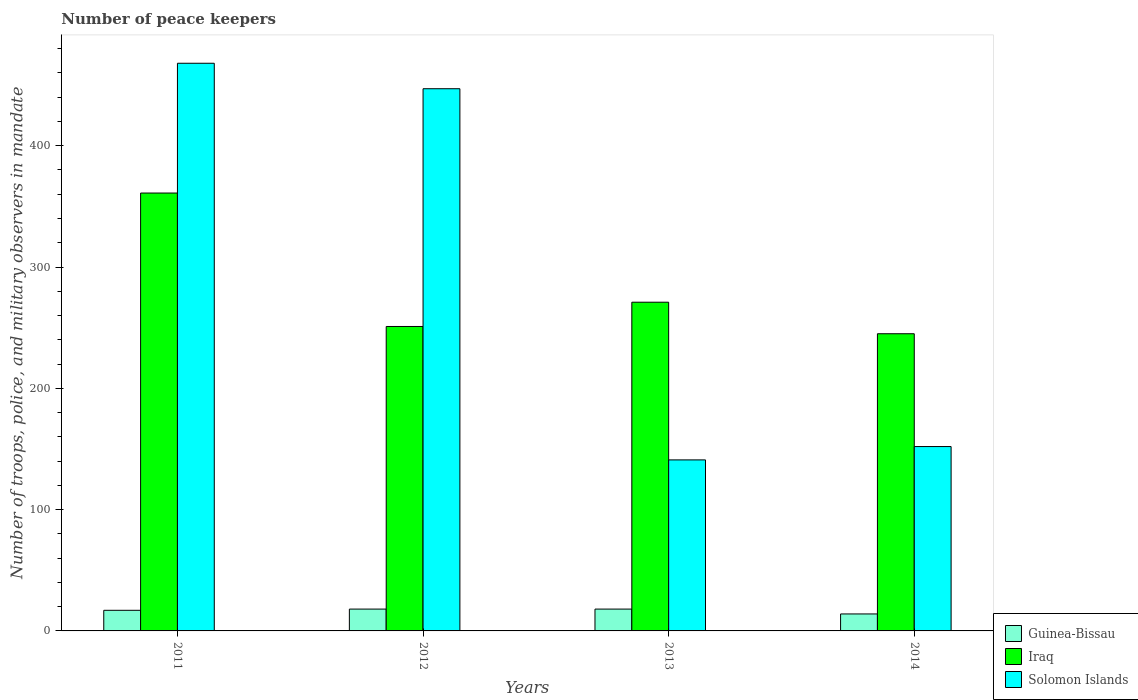How many different coloured bars are there?
Your response must be concise. 3. How many bars are there on the 4th tick from the right?
Offer a terse response. 3. What is the number of peace keepers in in Solomon Islands in 2013?
Ensure brevity in your answer.  141. Across all years, what is the maximum number of peace keepers in in Solomon Islands?
Provide a succinct answer. 468. What is the total number of peace keepers in in Solomon Islands in the graph?
Provide a short and direct response. 1208. What is the difference between the number of peace keepers in in Solomon Islands in 2012 and that in 2013?
Offer a terse response. 306. What is the difference between the number of peace keepers in in Guinea-Bissau in 2012 and the number of peace keepers in in Solomon Islands in 2013?
Your answer should be compact. -123. What is the average number of peace keepers in in Guinea-Bissau per year?
Offer a terse response. 16.75. In the year 2014, what is the difference between the number of peace keepers in in Guinea-Bissau and number of peace keepers in in Iraq?
Give a very brief answer. -231. What is the ratio of the number of peace keepers in in Solomon Islands in 2011 to that in 2012?
Your answer should be compact. 1.05. Is the number of peace keepers in in Solomon Islands in 2012 less than that in 2013?
Offer a very short reply. No. Is the difference between the number of peace keepers in in Guinea-Bissau in 2012 and 2013 greater than the difference between the number of peace keepers in in Iraq in 2012 and 2013?
Your answer should be compact. Yes. What is the difference between the highest and the second highest number of peace keepers in in Guinea-Bissau?
Offer a very short reply. 0. What is the difference between the highest and the lowest number of peace keepers in in Solomon Islands?
Give a very brief answer. 327. In how many years, is the number of peace keepers in in Iraq greater than the average number of peace keepers in in Iraq taken over all years?
Ensure brevity in your answer.  1. Is the sum of the number of peace keepers in in Iraq in 2013 and 2014 greater than the maximum number of peace keepers in in Guinea-Bissau across all years?
Your response must be concise. Yes. What does the 2nd bar from the left in 2014 represents?
Provide a succinct answer. Iraq. What does the 3rd bar from the right in 2011 represents?
Provide a succinct answer. Guinea-Bissau. How many bars are there?
Provide a short and direct response. 12. Are the values on the major ticks of Y-axis written in scientific E-notation?
Make the answer very short. No. Does the graph contain any zero values?
Offer a very short reply. No. How are the legend labels stacked?
Your response must be concise. Vertical. What is the title of the graph?
Keep it short and to the point. Number of peace keepers. What is the label or title of the Y-axis?
Give a very brief answer. Number of troops, police, and military observers in mandate. What is the Number of troops, police, and military observers in mandate of Iraq in 2011?
Keep it short and to the point. 361. What is the Number of troops, police, and military observers in mandate in Solomon Islands in 2011?
Your response must be concise. 468. What is the Number of troops, police, and military observers in mandate of Guinea-Bissau in 2012?
Ensure brevity in your answer.  18. What is the Number of troops, police, and military observers in mandate in Iraq in 2012?
Offer a terse response. 251. What is the Number of troops, police, and military observers in mandate in Solomon Islands in 2012?
Offer a terse response. 447. What is the Number of troops, police, and military observers in mandate in Guinea-Bissau in 2013?
Offer a very short reply. 18. What is the Number of troops, police, and military observers in mandate of Iraq in 2013?
Give a very brief answer. 271. What is the Number of troops, police, and military observers in mandate of Solomon Islands in 2013?
Offer a terse response. 141. What is the Number of troops, police, and military observers in mandate of Iraq in 2014?
Provide a short and direct response. 245. What is the Number of troops, police, and military observers in mandate in Solomon Islands in 2014?
Offer a very short reply. 152. Across all years, what is the maximum Number of troops, police, and military observers in mandate in Iraq?
Provide a succinct answer. 361. Across all years, what is the maximum Number of troops, police, and military observers in mandate of Solomon Islands?
Your answer should be compact. 468. Across all years, what is the minimum Number of troops, police, and military observers in mandate in Iraq?
Your answer should be compact. 245. Across all years, what is the minimum Number of troops, police, and military observers in mandate of Solomon Islands?
Make the answer very short. 141. What is the total Number of troops, police, and military observers in mandate of Guinea-Bissau in the graph?
Offer a terse response. 67. What is the total Number of troops, police, and military observers in mandate in Iraq in the graph?
Offer a very short reply. 1128. What is the total Number of troops, police, and military observers in mandate in Solomon Islands in the graph?
Ensure brevity in your answer.  1208. What is the difference between the Number of troops, police, and military observers in mandate in Iraq in 2011 and that in 2012?
Give a very brief answer. 110. What is the difference between the Number of troops, police, and military observers in mandate of Solomon Islands in 2011 and that in 2012?
Ensure brevity in your answer.  21. What is the difference between the Number of troops, police, and military observers in mandate of Solomon Islands in 2011 and that in 2013?
Give a very brief answer. 327. What is the difference between the Number of troops, police, and military observers in mandate of Iraq in 2011 and that in 2014?
Ensure brevity in your answer.  116. What is the difference between the Number of troops, police, and military observers in mandate in Solomon Islands in 2011 and that in 2014?
Provide a succinct answer. 316. What is the difference between the Number of troops, police, and military observers in mandate of Guinea-Bissau in 2012 and that in 2013?
Provide a succinct answer. 0. What is the difference between the Number of troops, police, and military observers in mandate of Iraq in 2012 and that in 2013?
Keep it short and to the point. -20. What is the difference between the Number of troops, police, and military observers in mandate of Solomon Islands in 2012 and that in 2013?
Provide a succinct answer. 306. What is the difference between the Number of troops, police, and military observers in mandate of Solomon Islands in 2012 and that in 2014?
Your answer should be very brief. 295. What is the difference between the Number of troops, police, and military observers in mandate in Solomon Islands in 2013 and that in 2014?
Ensure brevity in your answer.  -11. What is the difference between the Number of troops, police, and military observers in mandate in Guinea-Bissau in 2011 and the Number of troops, police, and military observers in mandate in Iraq in 2012?
Keep it short and to the point. -234. What is the difference between the Number of troops, police, and military observers in mandate in Guinea-Bissau in 2011 and the Number of troops, police, and military observers in mandate in Solomon Islands in 2012?
Give a very brief answer. -430. What is the difference between the Number of troops, police, and military observers in mandate of Iraq in 2011 and the Number of troops, police, and military observers in mandate of Solomon Islands in 2012?
Your answer should be compact. -86. What is the difference between the Number of troops, police, and military observers in mandate in Guinea-Bissau in 2011 and the Number of troops, police, and military observers in mandate in Iraq in 2013?
Offer a very short reply. -254. What is the difference between the Number of troops, police, and military observers in mandate of Guinea-Bissau in 2011 and the Number of troops, police, and military observers in mandate of Solomon Islands in 2013?
Offer a very short reply. -124. What is the difference between the Number of troops, police, and military observers in mandate of Iraq in 2011 and the Number of troops, police, and military observers in mandate of Solomon Islands in 2013?
Keep it short and to the point. 220. What is the difference between the Number of troops, police, and military observers in mandate of Guinea-Bissau in 2011 and the Number of troops, police, and military observers in mandate of Iraq in 2014?
Give a very brief answer. -228. What is the difference between the Number of troops, police, and military observers in mandate in Guinea-Bissau in 2011 and the Number of troops, police, and military observers in mandate in Solomon Islands in 2014?
Offer a terse response. -135. What is the difference between the Number of troops, police, and military observers in mandate of Iraq in 2011 and the Number of troops, police, and military observers in mandate of Solomon Islands in 2014?
Your answer should be compact. 209. What is the difference between the Number of troops, police, and military observers in mandate of Guinea-Bissau in 2012 and the Number of troops, police, and military observers in mandate of Iraq in 2013?
Keep it short and to the point. -253. What is the difference between the Number of troops, police, and military observers in mandate of Guinea-Bissau in 2012 and the Number of troops, police, and military observers in mandate of Solomon Islands in 2013?
Keep it short and to the point. -123. What is the difference between the Number of troops, police, and military observers in mandate of Iraq in 2012 and the Number of troops, police, and military observers in mandate of Solomon Islands in 2013?
Give a very brief answer. 110. What is the difference between the Number of troops, police, and military observers in mandate of Guinea-Bissau in 2012 and the Number of troops, police, and military observers in mandate of Iraq in 2014?
Provide a succinct answer. -227. What is the difference between the Number of troops, police, and military observers in mandate in Guinea-Bissau in 2012 and the Number of troops, police, and military observers in mandate in Solomon Islands in 2014?
Your answer should be compact. -134. What is the difference between the Number of troops, police, and military observers in mandate of Guinea-Bissau in 2013 and the Number of troops, police, and military observers in mandate of Iraq in 2014?
Ensure brevity in your answer.  -227. What is the difference between the Number of troops, police, and military observers in mandate of Guinea-Bissau in 2013 and the Number of troops, police, and military observers in mandate of Solomon Islands in 2014?
Your response must be concise. -134. What is the difference between the Number of troops, police, and military observers in mandate in Iraq in 2013 and the Number of troops, police, and military observers in mandate in Solomon Islands in 2014?
Offer a very short reply. 119. What is the average Number of troops, police, and military observers in mandate of Guinea-Bissau per year?
Make the answer very short. 16.75. What is the average Number of troops, police, and military observers in mandate of Iraq per year?
Your response must be concise. 282. What is the average Number of troops, police, and military observers in mandate of Solomon Islands per year?
Provide a succinct answer. 302. In the year 2011, what is the difference between the Number of troops, police, and military observers in mandate in Guinea-Bissau and Number of troops, police, and military observers in mandate in Iraq?
Keep it short and to the point. -344. In the year 2011, what is the difference between the Number of troops, police, and military observers in mandate in Guinea-Bissau and Number of troops, police, and military observers in mandate in Solomon Islands?
Ensure brevity in your answer.  -451. In the year 2011, what is the difference between the Number of troops, police, and military observers in mandate in Iraq and Number of troops, police, and military observers in mandate in Solomon Islands?
Make the answer very short. -107. In the year 2012, what is the difference between the Number of troops, police, and military observers in mandate of Guinea-Bissau and Number of troops, police, and military observers in mandate of Iraq?
Give a very brief answer. -233. In the year 2012, what is the difference between the Number of troops, police, and military observers in mandate in Guinea-Bissau and Number of troops, police, and military observers in mandate in Solomon Islands?
Provide a short and direct response. -429. In the year 2012, what is the difference between the Number of troops, police, and military observers in mandate in Iraq and Number of troops, police, and military observers in mandate in Solomon Islands?
Your response must be concise. -196. In the year 2013, what is the difference between the Number of troops, police, and military observers in mandate in Guinea-Bissau and Number of troops, police, and military observers in mandate in Iraq?
Ensure brevity in your answer.  -253. In the year 2013, what is the difference between the Number of troops, police, and military observers in mandate in Guinea-Bissau and Number of troops, police, and military observers in mandate in Solomon Islands?
Offer a terse response. -123. In the year 2013, what is the difference between the Number of troops, police, and military observers in mandate of Iraq and Number of troops, police, and military observers in mandate of Solomon Islands?
Give a very brief answer. 130. In the year 2014, what is the difference between the Number of troops, police, and military observers in mandate of Guinea-Bissau and Number of troops, police, and military observers in mandate of Iraq?
Offer a terse response. -231. In the year 2014, what is the difference between the Number of troops, police, and military observers in mandate in Guinea-Bissau and Number of troops, police, and military observers in mandate in Solomon Islands?
Your answer should be very brief. -138. In the year 2014, what is the difference between the Number of troops, police, and military observers in mandate in Iraq and Number of troops, police, and military observers in mandate in Solomon Islands?
Your response must be concise. 93. What is the ratio of the Number of troops, police, and military observers in mandate in Iraq in 2011 to that in 2012?
Offer a terse response. 1.44. What is the ratio of the Number of troops, police, and military observers in mandate in Solomon Islands in 2011 to that in 2012?
Provide a short and direct response. 1.05. What is the ratio of the Number of troops, police, and military observers in mandate of Guinea-Bissau in 2011 to that in 2013?
Offer a very short reply. 0.94. What is the ratio of the Number of troops, police, and military observers in mandate in Iraq in 2011 to that in 2013?
Keep it short and to the point. 1.33. What is the ratio of the Number of troops, police, and military observers in mandate in Solomon Islands in 2011 to that in 2013?
Your answer should be compact. 3.32. What is the ratio of the Number of troops, police, and military observers in mandate of Guinea-Bissau in 2011 to that in 2014?
Keep it short and to the point. 1.21. What is the ratio of the Number of troops, police, and military observers in mandate of Iraq in 2011 to that in 2014?
Your answer should be very brief. 1.47. What is the ratio of the Number of troops, police, and military observers in mandate in Solomon Islands in 2011 to that in 2014?
Your response must be concise. 3.08. What is the ratio of the Number of troops, police, and military observers in mandate of Guinea-Bissau in 2012 to that in 2013?
Give a very brief answer. 1. What is the ratio of the Number of troops, police, and military observers in mandate of Iraq in 2012 to that in 2013?
Provide a succinct answer. 0.93. What is the ratio of the Number of troops, police, and military observers in mandate in Solomon Islands in 2012 to that in 2013?
Your answer should be very brief. 3.17. What is the ratio of the Number of troops, police, and military observers in mandate of Iraq in 2012 to that in 2014?
Your answer should be compact. 1.02. What is the ratio of the Number of troops, police, and military observers in mandate in Solomon Islands in 2012 to that in 2014?
Your answer should be compact. 2.94. What is the ratio of the Number of troops, police, and military observers in mandate in Iraq in 2013 to that in 2014?
Keep it short and to the point. 1.11. What is the ratio of the Number of troops, police, and military observers in mandate of Solomon Islands in 2013 to that in 2014?
Ensure brevity in your answer.  0.93. What is the difference between the highest and the second highest Number of troops, police, and military observers in mandate of Iraq?
Keep it short and to the point. 90. What is the difference between the highest and the second highest Number of troops, police, and military observers in mandate of Solomon Islands?
Ensure brevity in your answer.  21. What is the difference between the highest and the lowest Number of troops, police, and military observers in mandate in Iraq?
Ensure brevity in your answer.  116. What is the difference between the highest and the lowest Number of troops, police, and military observers in mandate in Solomon Islands?
Keep it short and to the point. 327. 